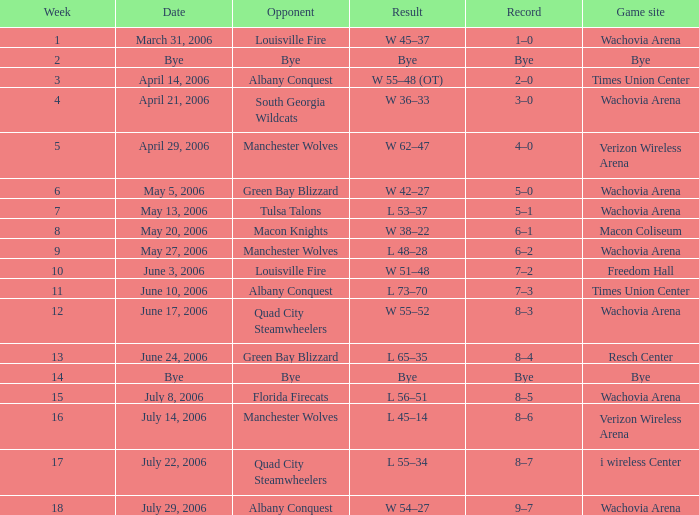Which team was the opponent one week before week 17 on june 17, 2006? Quad City Steamwheelers. 